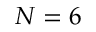Convert formula to latex. <formula><loc_0><loc_0><loc_500><loc_500>N = 6</formula> 